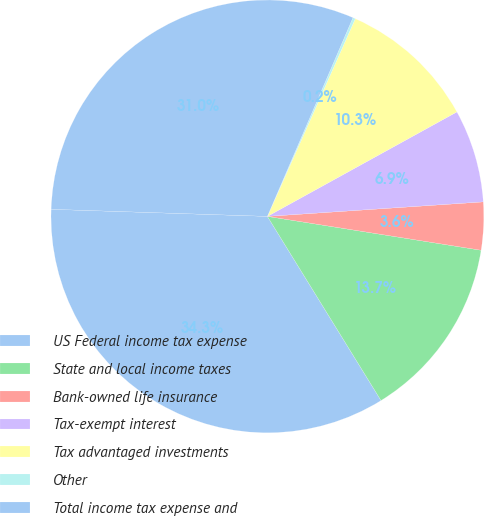<chart> <loc_0><loc_0><loc_500><loc_500><pie_chart><fcel>US Federal income tax expense<fcel>State and local income taxes<fcel>Bank-owned life insurance<fcel>Tax-exempt interest<fcel>Tax advantaged investments<fcel>Other<fcel>Total income tax expense and<nl><fcel>34.32%<fcel>13.7%<fcel>3.57%<fcel>6.95%<fcel>10.32%<fcel>0.19%<fcel>30.95%<nl></chart> 